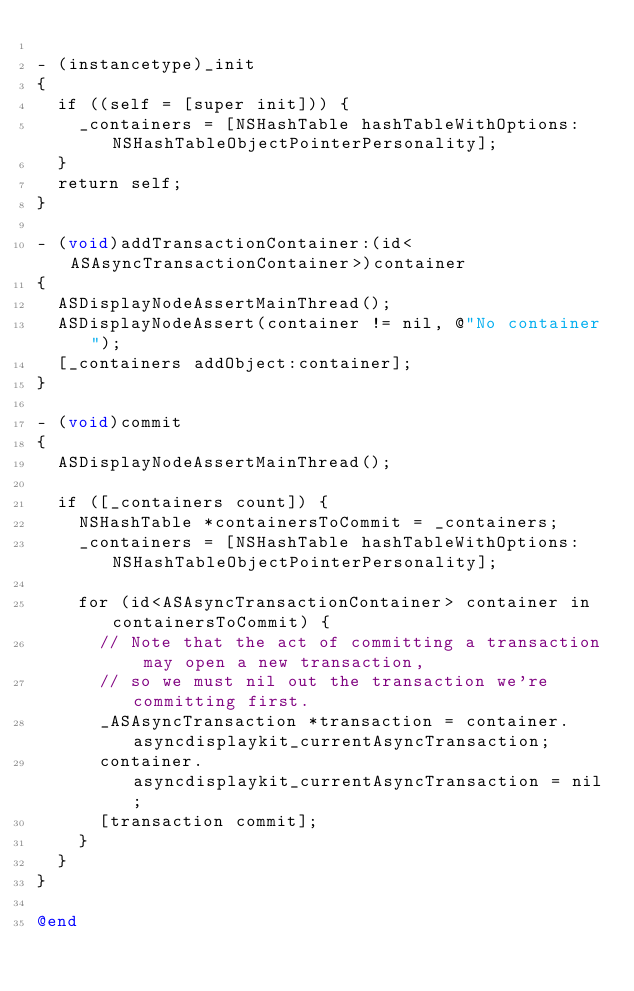<code> <loc_0><loc_0><loc_500><loc_500><_ObjectiveC_>
- (instancetype)_init
{
  if ((self = [super init])) {
    _containers = [NSHashTable hashTableWithOptions:NSHashTableObjectPointerPersonality];
  }
  return self;
}

- (void)addTransactionContainer:(id<ASAsyncTransactionContainer>)container
{
  ASDisplayNodeAssertMainThread();
  ASDisplayNodeAssert(container != nil, @"No container");
  [_containers addObject:container];
}

- (void)commit
{
  ASDisplayNodeAssertMainThread();

  if ([_containers count]) {
    NSHashTable *containersToCommit = _containers;
    _containers = [NSHashTable hashTableWithOptions:NSHashTableObjectPointerPersonality];

    for (id<ASAsyncTransactionContainer> container in containersToCommit) {
      // Note that the act of committing a transaction may open a new transaction,
      // so we must nil out the transaction we're committing first.
      _ASAsyncTransaction *transaction = container.asyncdisplaykit_currentAsyncTransaction;
      container.asyncdisplaykit_currentAsyncTransaction = nil;
      [transaction commit];
    }
  }
}

@end
</code> 